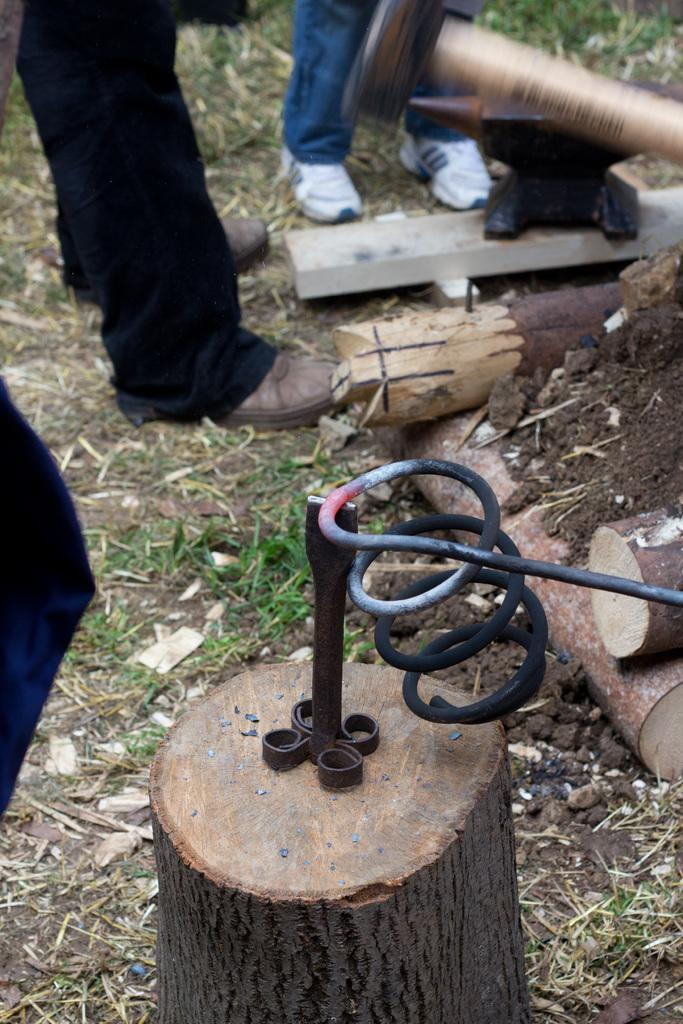What type of object is located at the bottom of the image? There is a wooden object at the bottom of the image. What type of vegetation can be seen in the image? Grass is visible in the image. How many people are present in the image? Two persons are standing in the middle of the image. What are the rods used for in the image? The purpose of the rods in the image is not specified, but they are present. What type of butter is being spread on the canvas in the image? There is no butter or canvas present in the image. What question are the two persons asking each other in the image? The image does not depict a conversation or question being asked between the two persons. 